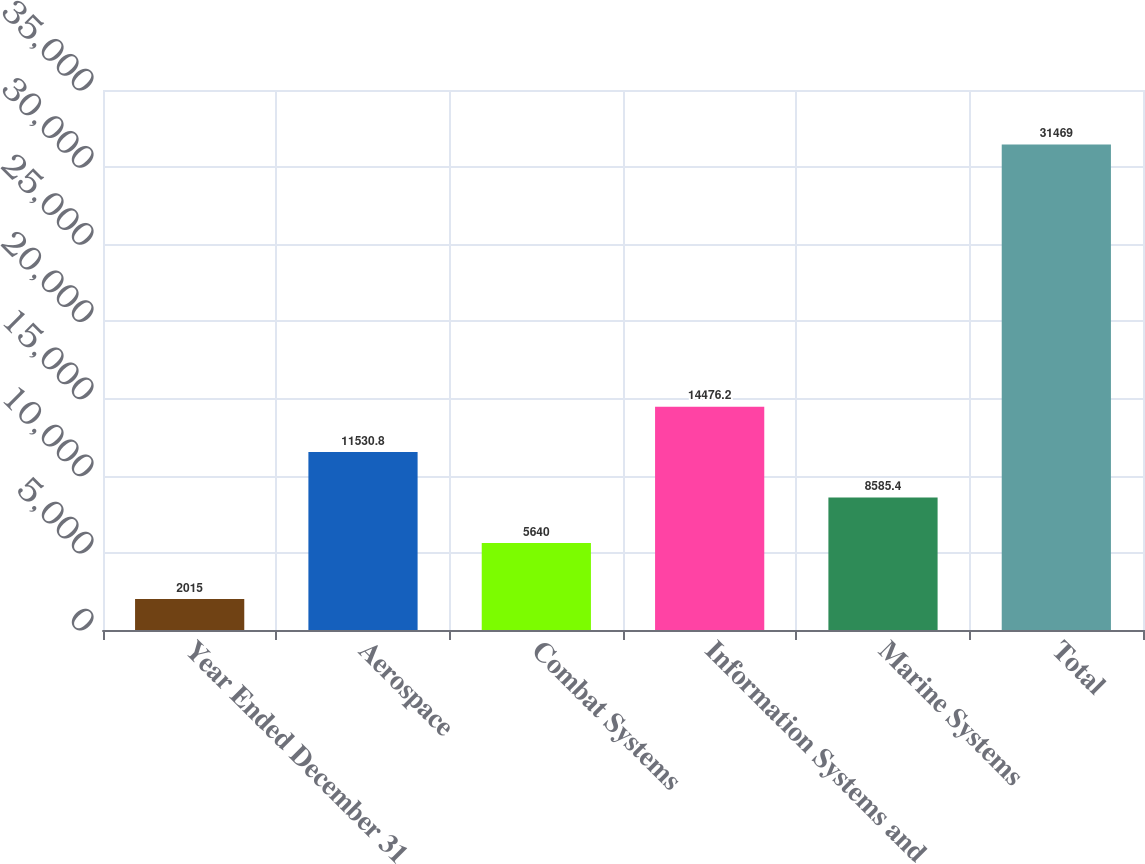Convert chart. <chart><loc_0><loc_0><loc_500><loc_500><bar_chart><fcel>Year Ended December 31<fcel>Aerospace<fcel>Combat Systems<fcel>Information Systems and<fcel>Marine Systems<fcel>Total<nl><fcel>2015<fcel>11530.8<fcel>5640<fcel>14476.2<fcel>8585.4<fcel>31469<nl></chart> 